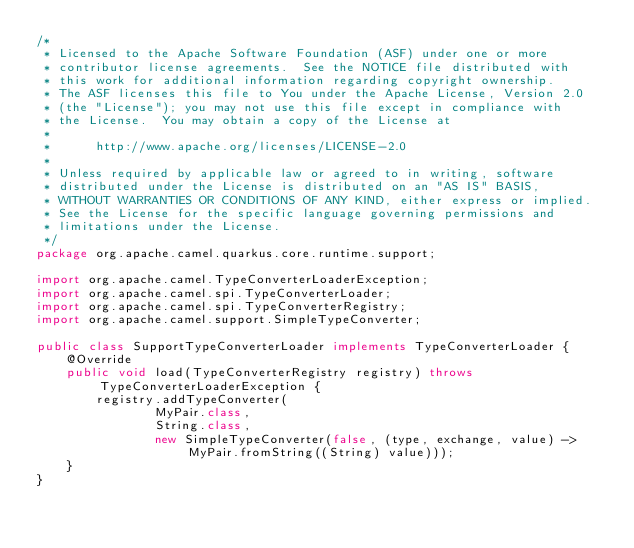Convert code to text. <code><loc_0><loc_0><loc_500><loc_500><_Java_>/*
 * Licensed to the Apache Software Foundation (ASF) under one or more
 * contributor license agreements.  See the NOTICE file distributed with
 * this work for additional information regarding copyright ownership.
 * The ASF licenses this file to You under the Apache License, Version 2.0
 * (the "License"); you may not use this file except in compliance with
 * the License.  You may obtain a copy of the License at
 *
 *      http://www.apache.org/licenses/LICENSE-2.0
 *
 * Unless required by applicable law or agreed to in writing, software
 * distributed under the License is distributed on an "AS IS" BASIS,
 * WITHOUT WARRANTIES OR CONDITIONS OF ANY KIND, either express or implied.
 * See the License for the specific language governing permissions and
 * limitations under the License.
 */
package org.apache.camel.quarkus.core.runtime.support;

import org.apache.camel.TypeConverterLoaderException;
import org.apache.camel.spi.TypeConverterLoader;
import org.apache.camel.spi.TypeConverterRegistry;
import org.apache.camel.support.SimpleTypeConverter;

public class SupportTypeConverterLoader implements TypeConverterLoader {
    @Override
    public void load(TypeConverterRegistry registry) throws TypeConverterLoaderException {
        registry.addTypeConverter(
                MyPair.class,
                String.class,
                new SimpleTypeConverter(false, (type, exchange, value) -> MyPair.fromString((String) value)));
    }
}
</code> 